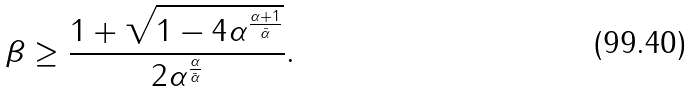Convert formula to latex. <formula><loc_0><loc_0><loc_500><loc_500>\beta \geq \frac { 1 + \sqrt { 1 - 4 \alpha ^ { \frac { \alpha + 1 } { \bar { \alpha } } } } } { 2 \alpha ^ { \frac { \alpha } { \bar { \alpha } } } } .</formula> 